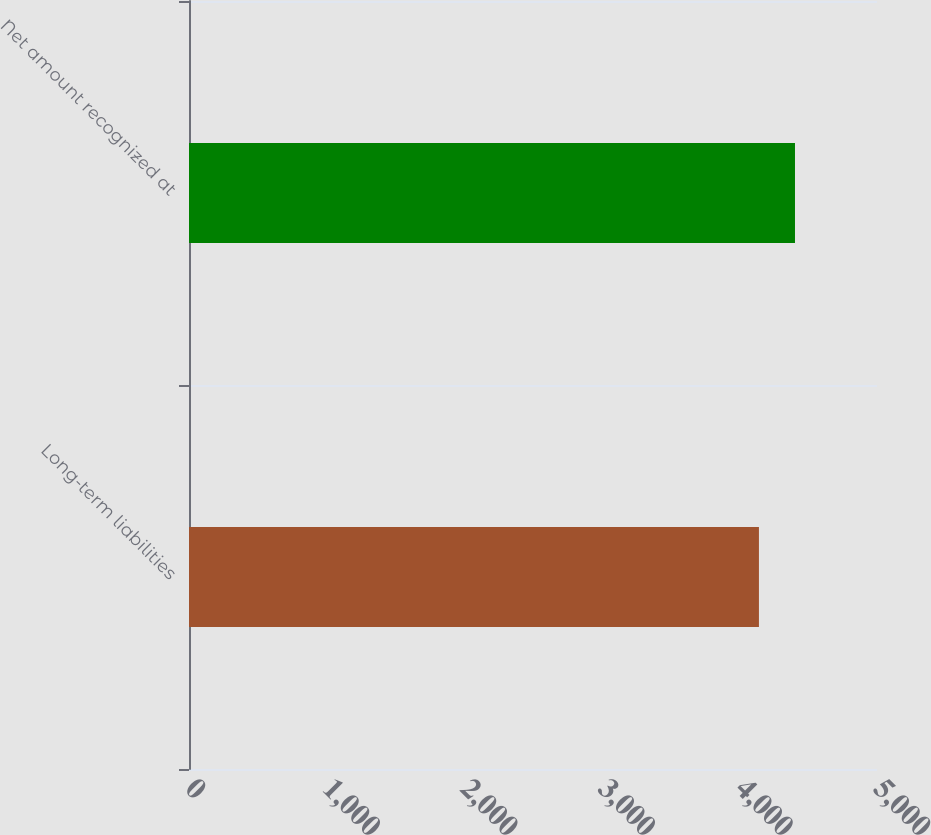Convert chart. <chart><loc_0><loc_0><loc_500><loc_500><bar_chart><fcel>Long-term liabilities<fcel>Net amount recognized at<nl><fcel>4142<fcel>4404<nl></chart> 